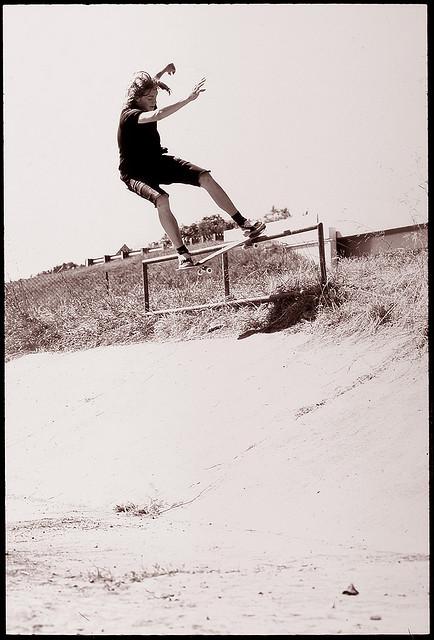What is the man doing?
Write a very short answer. Skateboarding. What is this man doing?
Keep it brief. Skateboarding. Is this a black and white photo?
Answer briefly. Yes. Is there anyone else in the photo besides the man?
Write a very short answer. No. 